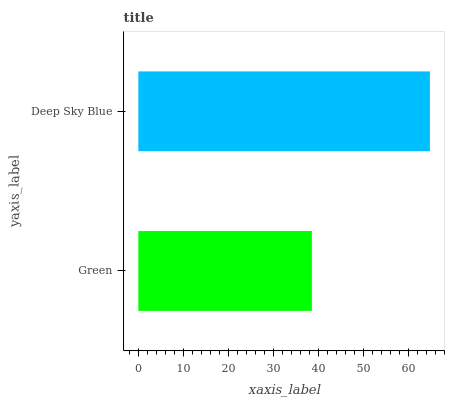Is Green the minimum?
Answer yes or no. Yes. Is Deep Sky Blue the maximum?
Answer yes or no. Yes. Is Deep Sky Blue the minimum?
Answer yes or no. No. Is Deep Sky Blue greater than Green?
Answer yes or no. Yes. Is Green less than Deep Sky Blue?
Answer yes or no. Yes. Is Green greater than Deep Sky Blue?
Answer yes or no. No. Is Deep Sky Blue less than Green?
Answer yes or no. No. Is Deep Sky Blue the high median?
Answer yes or no. Yes. Is Green the low median?
Answer yes or no. Yes. Is Green the high median?
Answer yes or no. No. Is Deep Sky Blue the low median?
Answer yes or no. No. 